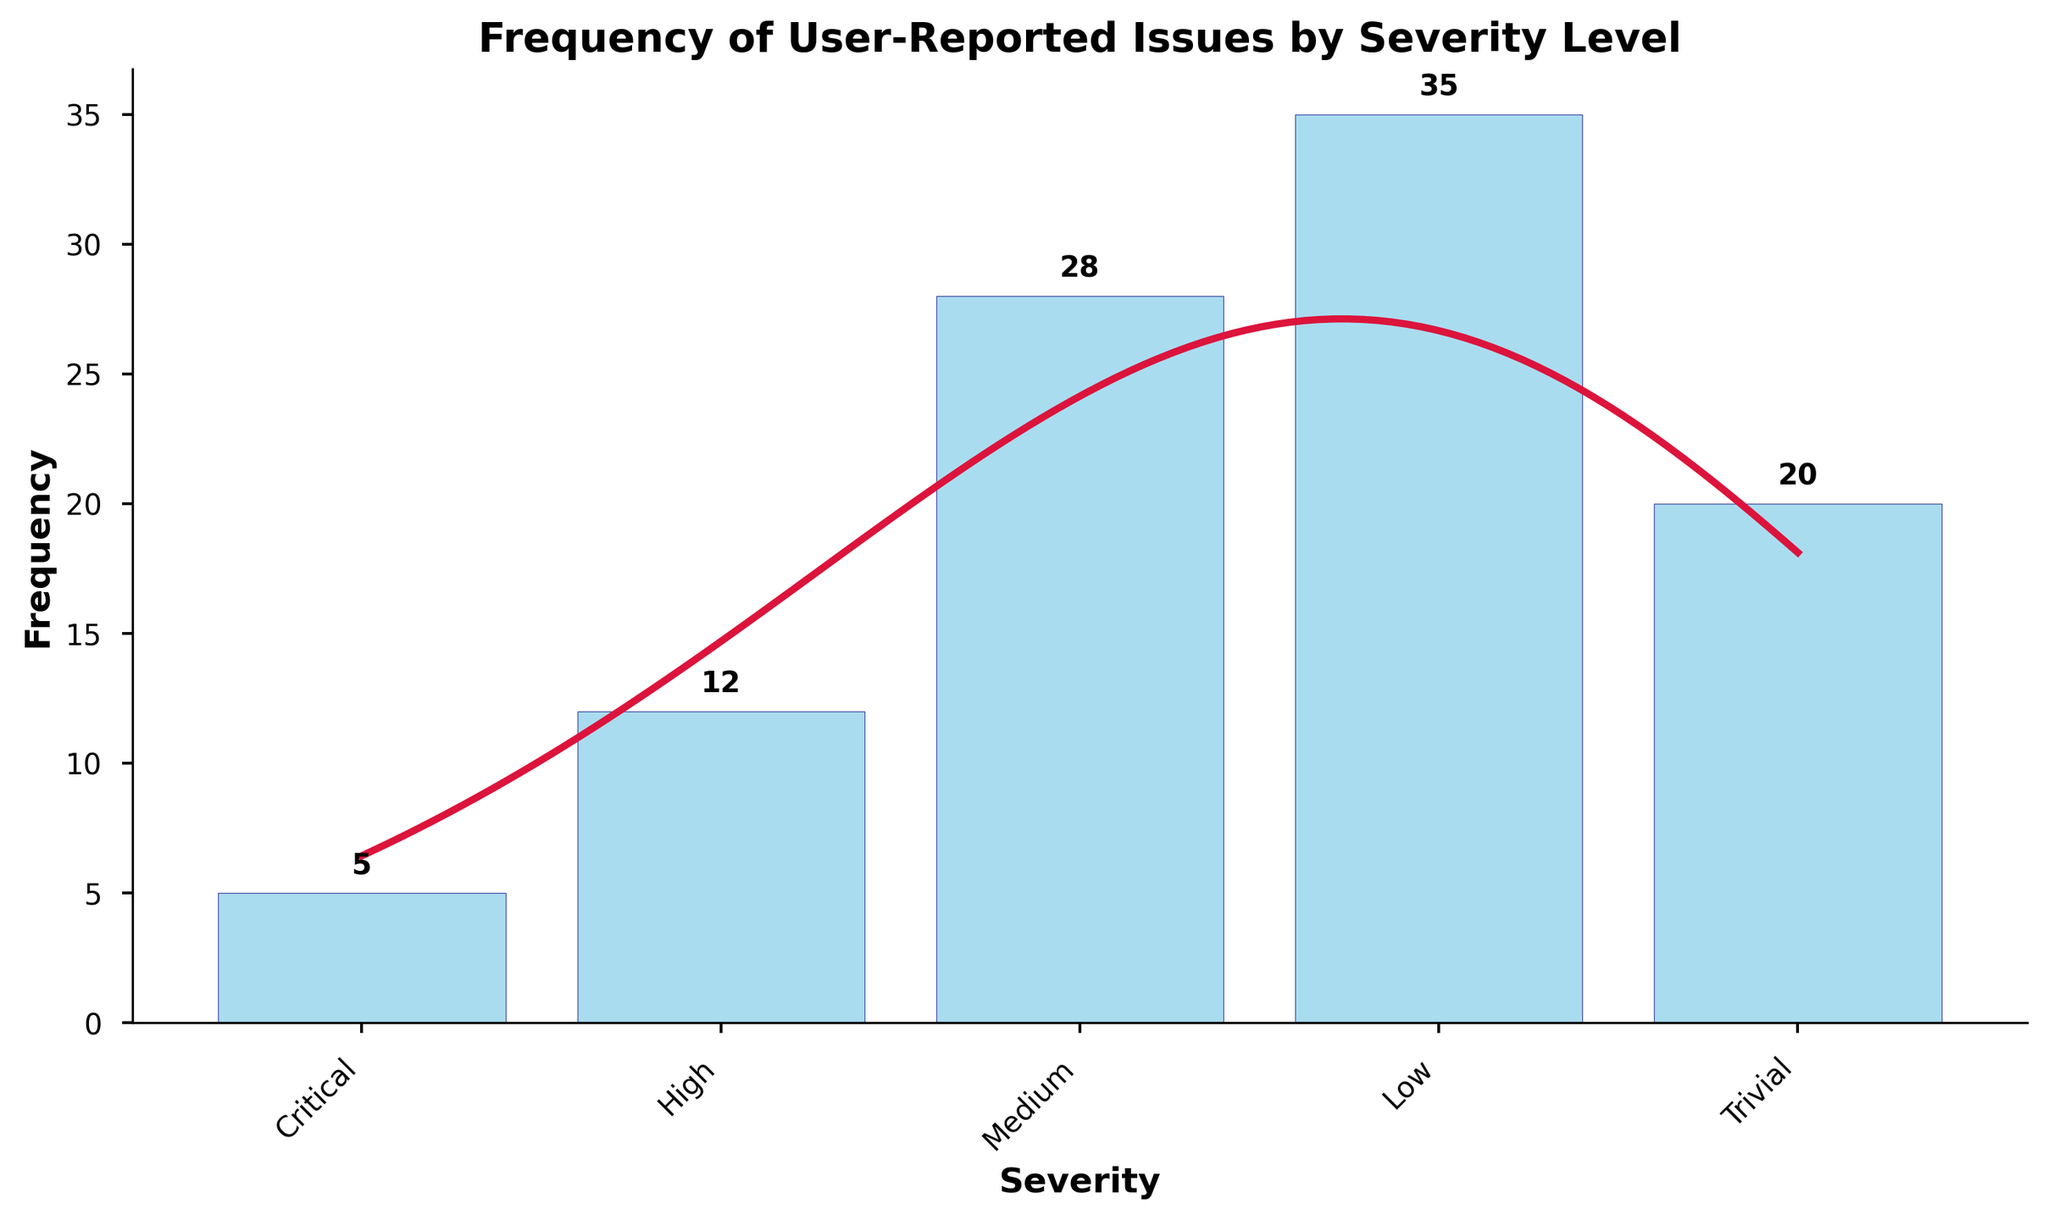What is the title of the figure? The title of the figure is written at the top and provides a description of what the figure is about. In this case, the title is "Frequency of User-Reported Issues by Severity Level".
Answer: Frequency of User-Reported Issues by Severity Level Which severity level has the highest frequency of issues reported? By looking at the bar heights in the histogram, the severity level with the highest bar represents the highest frequency. The 'Low' severity level has the highest frequency of issues reported.
Answer: Low How many severity levels are displayed in the figure? The number of category labels on the x-axis indicates the number of severity levels. There are five labels: Critical, High, Medium, Low, and Trivial.
Answer: Five What is the total number of issues reported? The total number of issues reported is the sum of the frequencies of all severity levels. Sum of frequencies is 5 + 12 + 28 + 35 + 20.
Answer: 100 Which severity levels have a reported frequency above 20? Observing the histogram bars, frequencies for 'Medium' (28) and 'Low' (35) are above 20.
Answer: Medium, Low What is the average frequency of issues for all severity levels? The average frequency is calculated by dividing the total number of issues by the number of severity levels. The total is 100, and there are 5 severity levels. So, 100 / 5 = 20.
Answer: 20 Is the frequency distribution skewed towards more minor or more critical issues? By comparing the heights of the bars, more minor issues ('Low', 'Trivial') have higher frequencies compared to more critical ('Critical', 'High').
Answer: More minor Which severity level is the closest to the average frequency value? The average frequency is 20. The reported frequencies are compared to this average. 'Trivial' has a frequency of 20, exactly matching the average.
Answer: Trivial Which two severity levels have the smallest difference in their frequency of issues? Comparing differences between frequencies: Critical and High (difference of 7), High and Medium (difference of 16), Medium and Low (difference of 7), Low and Trivial (difference of 15), Critical and Trivial (difference of 15). The smallest differences are both 7 for 'Critical & High' and 'Medium & Low'.
Answer: Critical & High, Medium & Low What is the overall trend depicted by the KDE curve? The KDE curve provides a smoothed representation of frequency distribution. It shows peaks at 'Medium' and 'Low' severity levels, indicating high densities.
Answer: Peaks at Medium and Low 